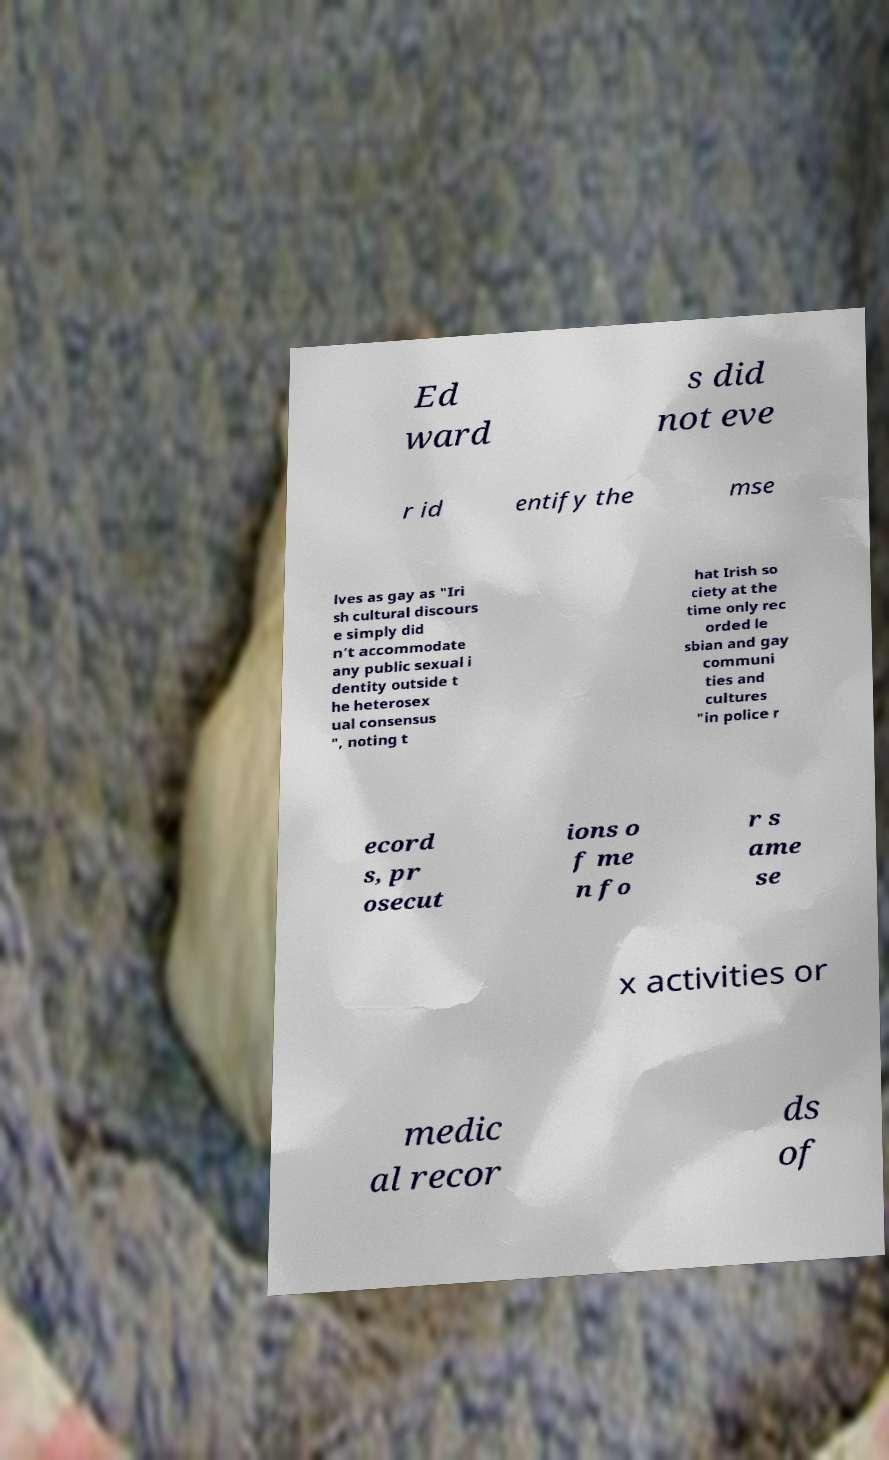Could you extract and type out the text from this image? Ed ward s did not eve r id entify the mse lves as gay as "Iri sh cultural discours e simply did n’t accommodate any public sexual i dentity outside t he heterosex ual consensus ", noting t hat Irish so ciety at the time only rec orded le sbian and gay communi ties and cultures "in police r ecord s, pr osecut ions o f me n fo r s ame se x activities or medic al recor ds of 